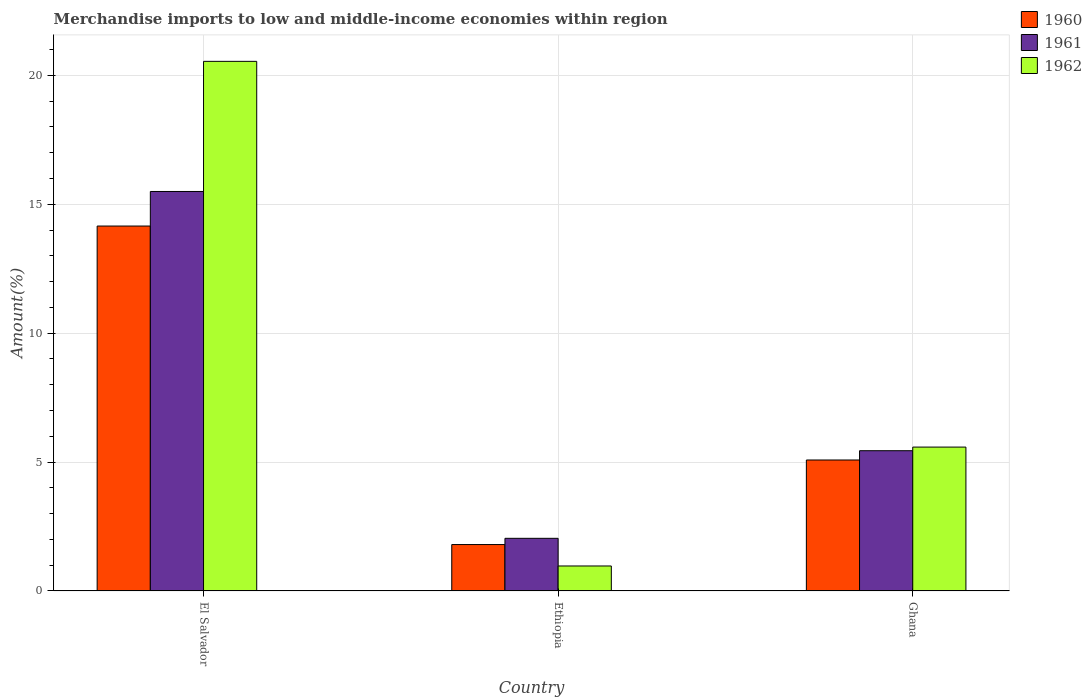How many bars are there on the 1st tick from the left?
Your answer should be very brief. 3. What is the label of the 3rd group of bars from the left?
Make the answer very short. Ghana. In how many cases, is the number of bars for a given country not equal to the number of legend labels?
Ensure brevity in your answer.  0. What is the percentage of amount earned from merchandise imports in 1961 in Ghana?
Offer a terse response. 5.44. Across all countries, what is the maximum percentage of amount earned from merchandise imports in 1960?
Make the answer very short. 14.16. Across all countries, what is the minimum percentage of amount earned from merchandise imports in 1962?
Your response must be concise. 0.97. In which country was the percentage of amount earned from merchandise imports in 1960 maximum?
Provide a short and direct response. El Salvador. In which country was the percentage of amount earned from merchandise imports in 1961 minimum?
Make the answer very short. Ethiopia. What is the total percentage of amount earned from merchandise imports in 1962 in the graph?
Offer a terse response. 27.1. What is the difference between the percentage of amount earned from merchandise imports in 1962 in Ethiopia and that in Ghana?
Give a very brief answer. -4.61. What is the difference between the percentage of amount earned from merchandise imports in 1961 in Ghana and the percentage of amount earned from merchandise imports in 1962 in Ethiopia?
Provide a succinct answer. 4.47. What is the average percentage of amount earned from merchandise imports in 1962 per country?
Offer a very short reply. 9.03. What is the difference between the percentage of amount earned from merchandise imports of/in 1960 and percentage of amount earned from merchandise imports of/in 1962 in El Salvador?
Your response must be concise. -6.39. What is the ratio of the percentage of amount earned from merchandise imports in 1961 in El Salvador to that in Ghana?
Offer a terse response. 2.85. Is the percentage of amount earned from merchandise imports in 1962 in Ethiopia less than that in Ghana?
Your response must be concise. Yes. Is the difference between the percentage of amount earned from merchandise imports in 1960 in El Salvador and Ghana greater than the difference between the percentage of amount earned from merchandise imports in 1962 in El Salvador and Ghana?
Offer a very short reply. No. What is the difference between the highest and the second highest percentage of amount earned from merchandise imports in 1960?
Provide a succinct answer. -3.28. What is the difference between the highest and the lowest percentage of amount earned from merchandise imports in 1960?
Offer a terse response. 12.36. In how many countries, is the percentage of amount earned from merchandise imports in 1960 greater than the average percentage of amount earned from merchandise imports in 1960 taken over all countries?
Make the answer very short. 1. Is the sum of the percentage of amount earned from merchandise imports in 1961 in Ethiopia and Ghana greater than the maximum percentage of amount earned from merchandise imports in 1962 across all countries?
Your answer should be compact. No. What does the 3rd bar from the right in Ethiopia represents?
Offer a very short reply. 1960. Is it the case that in every country, the sum of the percentage of amount earned from merchandise imports in 1962 and percentage of amount earned from merchandise imports in 1960 is greater than the percentage of amount earned from merchandise imports in 1961?
Keep it short and to the point. Yes. How many bars are there?
Your answer should be compact. 9. Are all the bars in the graph horizontal?
Your answer should be compact. No. How many countries are there in the graph?
Offer a terse response. 3. What is the difference between two consecutive major ticks on the Y-axis?
Your response must be concise. 5. Are the values on the major ticks of Y-axis written in scientific E-notation?
Give a very brief answer. No. Does the graph contain any zero values?
Your answer should be compact. No. Does the graph contain grids?
Your response must be concise. Yes. Where does the legend appear in the graph?
Your response must be concise. Top right. What is the title of the graph?
Make the answer very short. Merchandise imports to low and middle-income economies within region. What is the label or title of the X-axis?
Provide a succinct answer. Country. What is the label or title of the Y-axis?
Offer a terse response. Amount(%). What is the Amount(%) in 1960 in El Salvador?
Provide a succinct answer. 14.16. What is the Amount(%) of 1961 in El Salvador?
Provide a succinct answer. 15.5. What is the Amount(%) of 1962 in El Salvador?
Make the answer very short. 20.55. What is the Amount(%) in 1960 in Ethiopia?
Your answer should be very brief. 1.8. What is the Amount(%) of 1961 in Ethiopia?
Provide a short and direct response. 2.04. What is the Amount(%) in 1962 in Ethiopia?
Your answer should be very brief. 0.97. What is the Amount(%) in 1960 in Ghana?
Keep it short and to the point. 5.08. What is the Amount(%) of 1961 in Ghana?
Ensure brevity in your answer.  5.44. What is the Amount(%) of 1962 in Ghana?
Provide a succinct answer. 5.58. Across all countries, what is the maximum Amount(%) in 1960?
Your answer should be very brief. 14.16. Across all countries, what is the maximum Amount(%) in 1961?
Make the answer very short. 15.5. Across all countries, what is the maximum Amount(%) of 1962?
Provide a succinct answer. 20.55. Across all countries, what is the minimum Amount(%) in 1960?
Your response must be concise. 1.8. Across all countries, what is the minimum Amount(%) of 1961?
Offer a terse response. 2.04. Across all countries, what is the minimum Amount(%) of 1962?
Provide a succinct answer. 0.97. What is the total Amount(%) in 1960 in the graph?
Your answer should be very brief. 21.04. What is the total Amount(%) in 1961 in the graph?
Ensure brevity in your answer.  22.98. What is the total Amount(%) in 1962 in the graph?
Offer a terse response. 27.1. What is the difference between the Amount(%) in 1960 in El Salvador and that in Ethiopia?
Offer a very short reply. 12.36. What is the difference between the Amount(%) in 1961 in El Salvador and that in Ethiopia?
Offer a very short reply. 13.46. What is the difference between the Amount(%) in 1962 in El Salvador and that in Ethiopia?
Offer a terse response. 19.58. What is the difference between the Amount(%) in 1960 in El Salvador and that in Ghana?
Ensure brevity in your answer.  9.08. What is the difference between the Amount(%) of 1961 in El Salvador and that in Ghana?
Ensure brevity in your answer.  10.06. What is the difference between the Amount(%) of 1962 in El Salvador and that in Ghana?
Offer a terse response. 14.96. What is the difference between the Amount(%) in 1960 in Ethiopia and that in Ghana?
Offer a very short reply. -3.28. What is the difference between the Amount(%) in 1961 in Ethiopia and that in Ghana?
Your answer should be compact. -3.4. What is the difference between the Amount(%) of 1962 in Ethiopia and that in Ghana?
Your answer should be compact. -4.61. What is the difference between the Amount(%) of 1960 in El Salvador and the Amount(%) of 1961 in Ethiopia?
Offer a terse response. 12.11. What is the difference between the Amount(%) of 1960 in El Salvador and the Amount(%) of 1962 in Ethiopia?
Offer a very short reply. 13.19. What is the difference between the Amount(%) in 1961 in El Salvador and the Amount(%) in 1962 in Ethiopia?
Ensure brevity in your answer.  14.53. What is the difference between the Amount(%) of 1960 in El Salvador and the Amount(%) of 1961 in Ghana?
Make the answer very short. 8.72. What is the difference between the Amount(%) of 1960 in El Salvador and the Amount(%) of 1962 in Ghana?
Your answer should be compact. 8.57. What is the difference between the Amount(%) in 1961 in El Salvador and the Amount(%) in 1962 in Ghana?
Offer a very short reply. 9.92. What is the difference between the Amount(%) in 1960 in Ethiopia and the Amount(%) in 1961 in Ghana?
Provide a succinct answer. -3.64. What is the difference between the Amount(%) of 1960 in Ethiopia and the Amount(%) of 1962 in Ghana?
Your response must be concise. -3.78. What is the difference between the Amount(%) in 1961 in Ethiopia and the Amount(%) in 1962 in Ghana?
Your response must be concise. -3.54. What is the average Amount(%) in 1960 per country?
Keep it short and to the point. 7.01. What is the average Amount(%) in 1961 per country?
Provide a succinct answer. 7.66. What is the average Amount(%) of 1962 per country?
Provide a short and direct response. 9.03. What is the difference between the Amount(%) of 1960 and Amount(%) of 1961 in El Salvador?
Your answer should be very brief. -1.34. What is the difference between the Amount(%) of 1960 and Amount(%) of 1962 in El Salvador?
Your response must be concise. -6.39. What is the difference between the Amount(%) of 1961 and Amount(%) of 1962 in El Salvador?
Make the answer very short. -5.05. What is the difference between the Amount(%) of 1960 and Amount(%) of 1961 in Ethiopia?
Your answer should be compact. -0.24. What is the difference between the Amount(%) in 1960 and Amount(%) in 1962 in Ethiopia?
Ensure brevity in your answer.  0.83. What is the difference between the Amount(%) in 1961 and Amount(%) in 1962 in Ethiopia?
Make the answer very short. 1.07. What is the difference between the Amount(%) in 1960 and Amount(%) in 1961 in Ghana?
Your answer should be very brief. -0.36. What is the difference between the Amount(%) in 1960 and Amount(%) in 1962 in Ghana?
Offer a very short reply. -0.5. What is the difference between the Amount(%) in 1961 and Amount(%) in 1962 in Ghana?
Keep it short and to the point. -0.14. What is the ratio of the Amount(%) of 1960 in El Salvador to that in Ethiopia?
Offer a terse response. 7.86. What is the ratio of the Amount(%) of 1961 in El Salvador to that in Ethiopia?
Ensure brevity in your answer.  7.59. What is the ratio of the Amount(%) of 1962 in El Salvador to that in Ethiopia?
Your answer should be very brief. 21.18. What is the ratio of the Amount(%) of 1960 in El Salvador to that in Ghana?
Offer a very short reply. 2.79. What is the ratio of the Amount(%) in 1961 in El Salvador to that in Ghana?
Ensure brevity in your answer.  2.85. What is the ratio of the Amount(%) in 1962 in El Salvador to that in Ghana?
Your answer should be compact. 3.68. What is the ratio of the Amount(%) of 1960 in Ethiopia to that in Ghana?
Your answer should be very brief. 0.35. What is the ratio of the Amount(%) of 1961 in Ethiopia to that in Ghana?
Offer a terse response. 0.38. What is the ratio of the Amount(%) of 1962 in Ethiopia to that in Ghana?
Your answer should be compact. 0.17. What is the difference between the highest and the second highest Amount(%) in 1960?
Provide a short and direct response. 9.08. What is the difference between the highest and the second highest Amount(%) in 1961?
Keep it short and to the point. 10.06. What is the difference between the highest and the second highest Amount(%) in 1962?
Keep it short and to the point. 14.96. What is the difference between the highest and the lowest Amount(%) of 1960?
Keep it short and to the point. 12.36. What is the difference between the highest and the lowest Amount(%) of 1961?
Your answer should be very brief. 13.46. What is the difference between the highest and the lowest Amount(%) in 1962?
Provide a succinct answer. 19.58. 